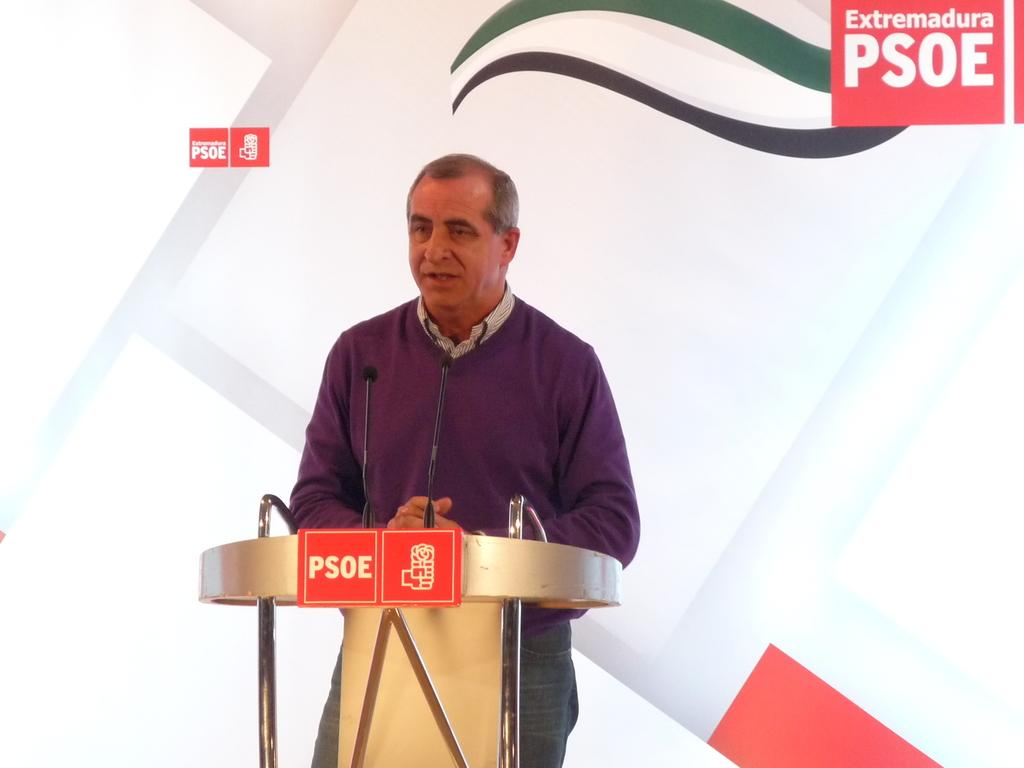What is the man near in the foreground of the image? There is a man standing near a podium in the foreground of the image. What objects are near the man that might be used for speaking? There are microphones near the man. What can be seen in the background of the image? There is a white banner in the background of the image. What is featured on the banner? There are logos on the banner. How does the man blow out the candles on the cake in the image? There is no cake or candles present in the image; it features a man standing near a podium with microphones and a white banner with logos in the background. 